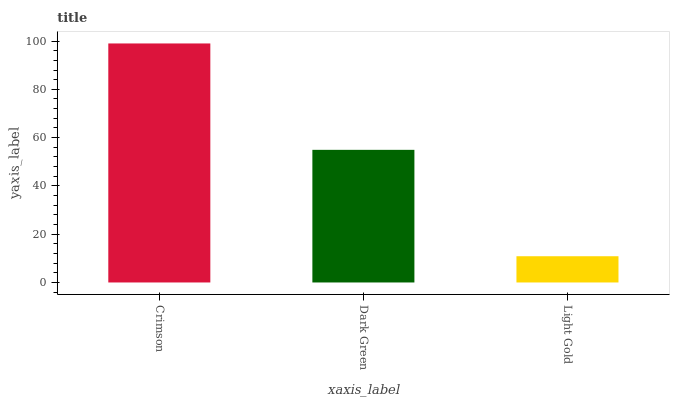Is Light Gold the minimum?
Answer yes or no. Yes. Is Crimson the maximum?
Answer yes or no. Yes. Is Dark Green the minimum?
Answer yes or no. No. Is Dark Green the maximum?
Answer yes or no. No. Is Crimson greater than Dark Green?
Answer yes or no. Yes. Is Dark Green less than Crimson?
Answer yes or no. Yes. Is Dark Green greater than Crimson?
Answer yes or no. No. Is Crimson less than Dark Green?
Answer yes or no. No. Is Dark Green the high median?
Answer yes or no. Yes. Is Dark Green the low median?
Answer yes or no. Yes. Is Crimson the high median?
Answer yes or no. No. Is Crimson the low median?
Answer yes or no. No. 